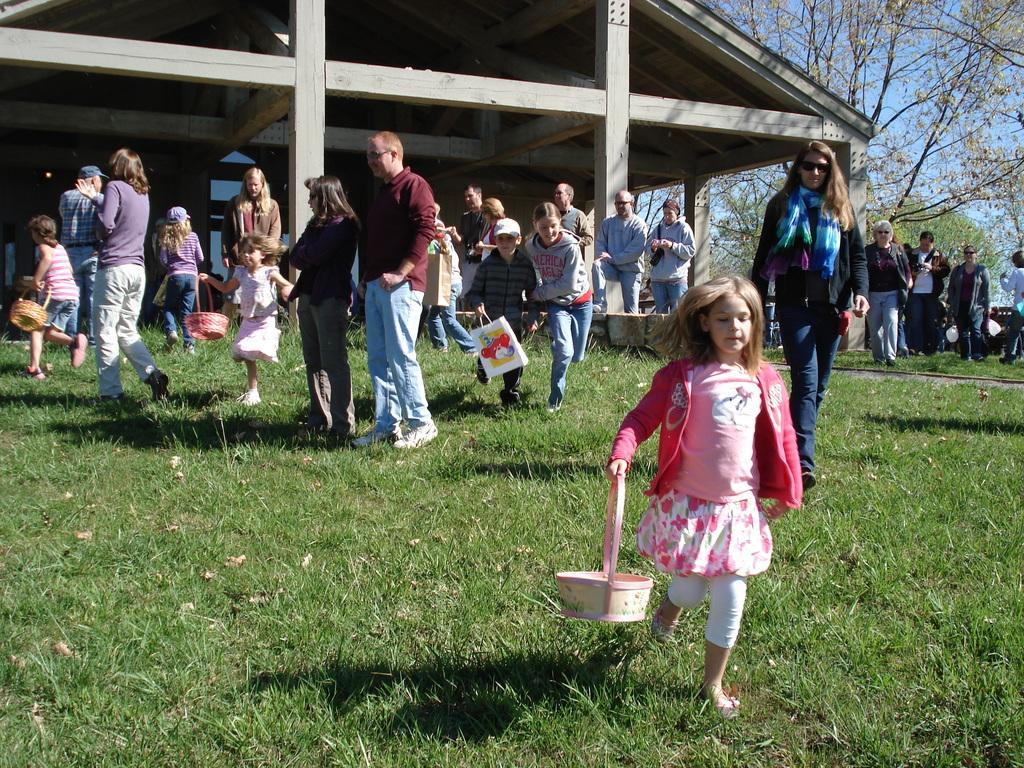What is located in the foreground of the image? There are people in the foreground of the image. What type of vegetation is at the bottom of the image? There is green grass at the bottom of the image. What architectural feature can be seen in the background of the image? There are pillars with a roof in the background of the image. What else is visible in the background of the image? There are trees in the background of the image. What is visible at the top of the image? The sky is visible at the top of the image. What type of voice can be heard coming from the trees in the image? There is no voice coming from the trees in the image, as trees do not produce sounds. What taste is associated with the green grass in the image? The taste of the grass cannot be determined from the image, as taste is not a visual characteristic. 